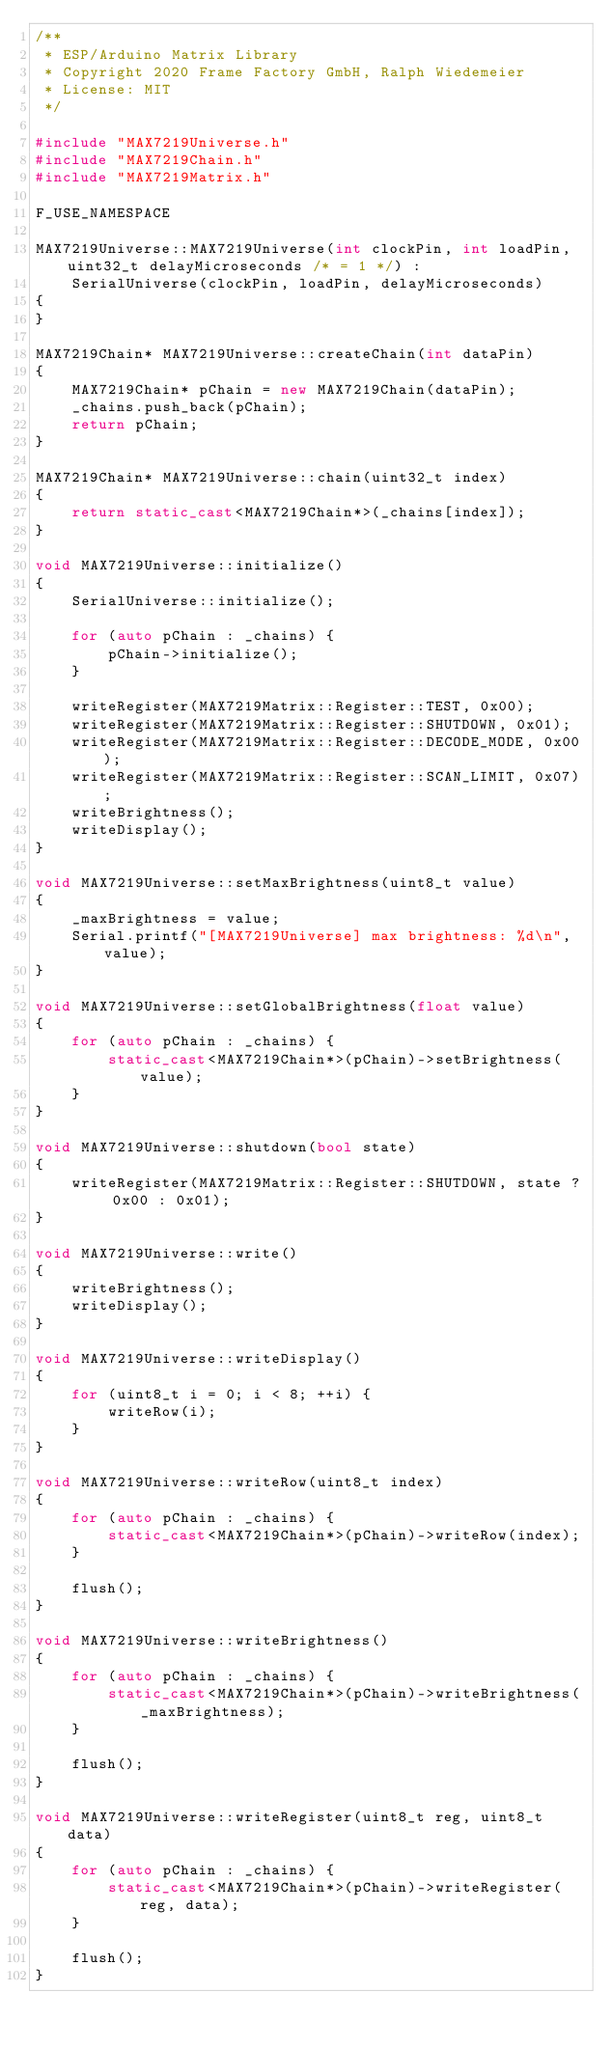Convert code to text. <code><loc_0><loc_0><loc_500><loc_500><_C++_>/**
 * ESP/Arduino Matrix Library
 * Copyright 2020 Frame Factory GmbH, Ralph Wiedemeier
 * License: MIT
 */

#include "MAX7219Universe.h"
#include "MAX7219Chain.h"
#include "MAX7219Matrix.h"

F_USE_NAMESPACE

MAX7219Universe::MAX7219Universe(int clockPin, int loadPin, uint32_t delayMicroseconds /* = 1 */) :
    SerialUniverse(clockPin, loadPin, delayMicroseconds)
{
}

MAX7219Chain* MAX7219Universe::createChain(int dataPin)
{
    MAX7219Chain* pChain = new MAX7219Chain(dataPin);
    _chains.push_back(pChain);
    return pChain;
}

MAX7219Chain* MAX7219Universe::chain(uint32_t index)
{
    return static_cast<MAX7219Chain*>(_chains[index]);
}

void MAX7219Universe::initialize()
{
    SerialUniverse::initialize();

    for (auto pChain : _chains) {
        pChain->initialize();
    }

    writeRegister(MAX7219Matrix::Register::TEST, 0x00);
    writeRegister(MAX7219Matrix::Register::SHUTDOWN, 0x01);
    writeRegister(MAX7219Matrix::Register::DECODE_MODE, 0x00);
    writeRegister(MAX7219Matrix::Register::SCAN_LIMIT, 0x07);
    writeBrightness();
    writeDisplay();
}

void MAX7219Universe::setMaxBrightness(uint8_t value)
{
    _maxBrightness = value;
    Serial.printf("[MAX7219Universe] max brightness: %d\n", value);
}

void MAX7219Universe::setGlobalBrightness(float value)
{
    for (auto pChain : _chains) {
        static_cast<MAX7219Chain*>(pChain)->setBrightness(value);
    }
}

void MAX7219Universe::shutdown(bool state)
{
    writeRegister(MAX7219Matrix::Register::SHUTDOWN, state ? 0x00 : 0x01);
}

void MAX7219Universe::write()
{
    writeBrightness();
    writeDisplay();
}

void MAX7219Universe::writeDisplay()
{
    for (uint8_t i = 0; i < 8; ++i) {
        writeRow(i);
    }
} 

void MAX7219Universe::writeRow(uint8_t index)
{
    for (auto pChain : _chains) {
        static_cast<MAX7219Chain*>(pChain)->writeRow(index);
    }

    flush();
}

void MAX7219Universe::writeBrightness()
{
    for (auto pChain : _chains) {
        static_cast<MAX7219Chain*>(pChain)->writeBrightness(_maxBrightness);
    }

    flush();
}

void MAX7219Universe::writeRegister(uint8_t reg, uint8_t data)
{
    for (auto pChain : _chains) {
        static_cast<MAX7219Chain*>(pChain)->writeRegister(reg, data);
    }

    flush();
}
</code> 